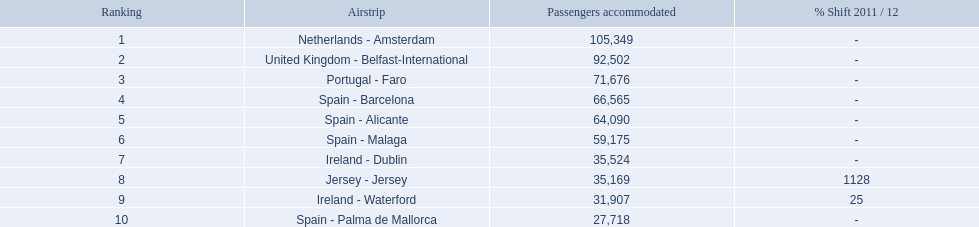What are the airports? Netherlands - Amsterdam, United Kingdom - Belfast-International, Portugal - Faro, Spain - Barcelona, Spain - Alicante, Spain - Malaga, Ireland - Dublin, Jersey - Jersey, Ireland - Waterford, Spain - Palma de Mallorca. Of these which has the least amount of passengers? Spain - Palma de Mallorca. 